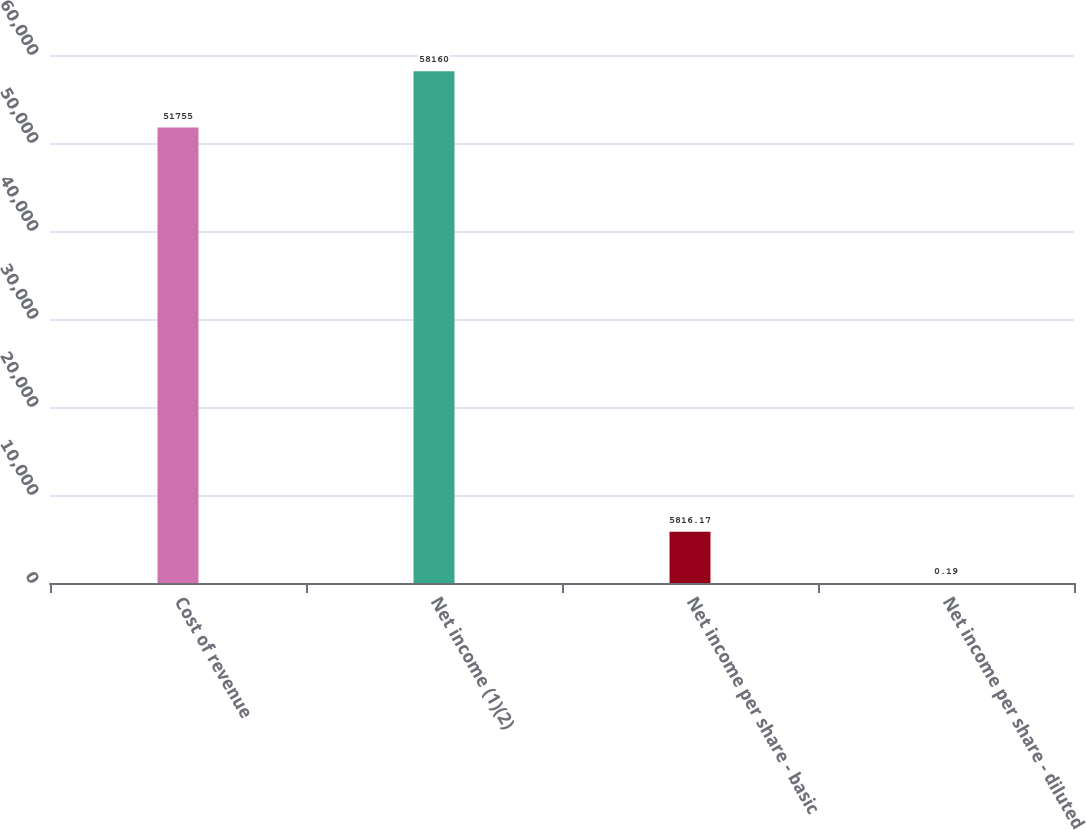Convert chart to OTSL. <chart><loc_0><loc_0><loc_500><loc_500><bar_chart><fcel>Cost of revenue<fcel>Net income (1)(2)<fcel>Net income per share - basic<fcel>Net income per share - diluted<nl><fcel>51755<fcel>58160<fcel>5816.17<fcel>0.19<nl></chart> 